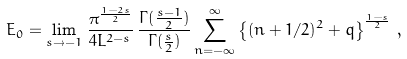Convert formula to latex. <formula><loc_0><loc_0><loc_500><loc_500>E _ { 0 } = \lim _ { s \rightarrow - 1 } \, \frac { \pi ^ { \frac { 1 - 2 s } { 2 } } } { 4 L ^ { 2 - s } } \, \frac { \Gamma ( \frac { s - 1 } { 2 } ) } { \Gamma ( \frac { s } { 2 } ) } \sum _ { n = - \infty } ^ { \infty } \left \{ ( n + 1 / 2 ) ^ { 2 } + q \right \} ^ { \frac { 1 - s } { 2 } } \, ,</formula> 